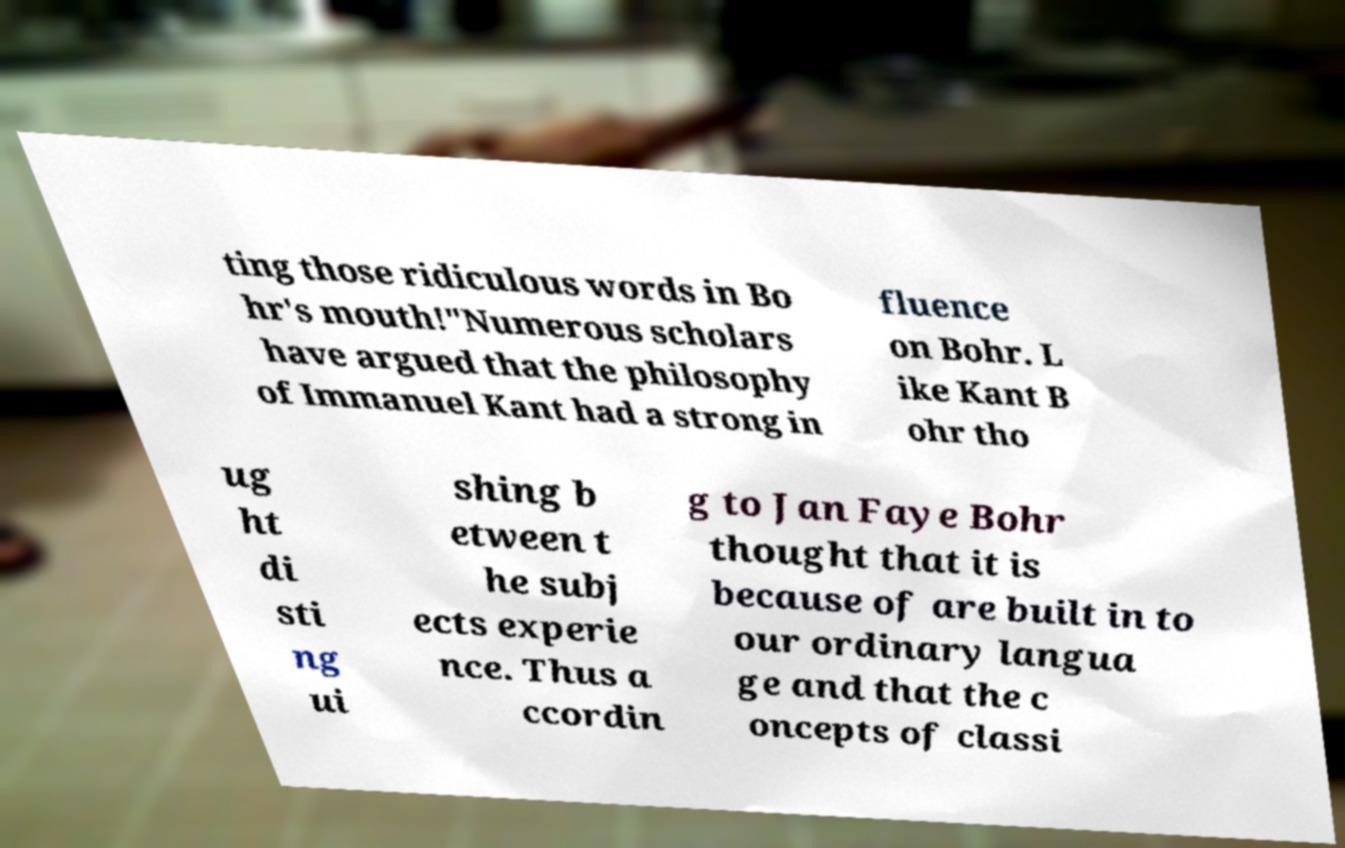Please read and relay the text visible in this image. What does it say? ting those ridiculous words in Bo hr's mouth!"Numerous scholars have argued that the philosophy of Immanuel Kant had a strong in fluence on Bohr. L ike Kant B ohr tho ug ht di sti ng ui shing b etween t he subj ects experie nce. Thus a ccordin g to Jan Faye Bohr thought that it is because of are built in to our ordinary langua ge and that the c oncepts of classi 